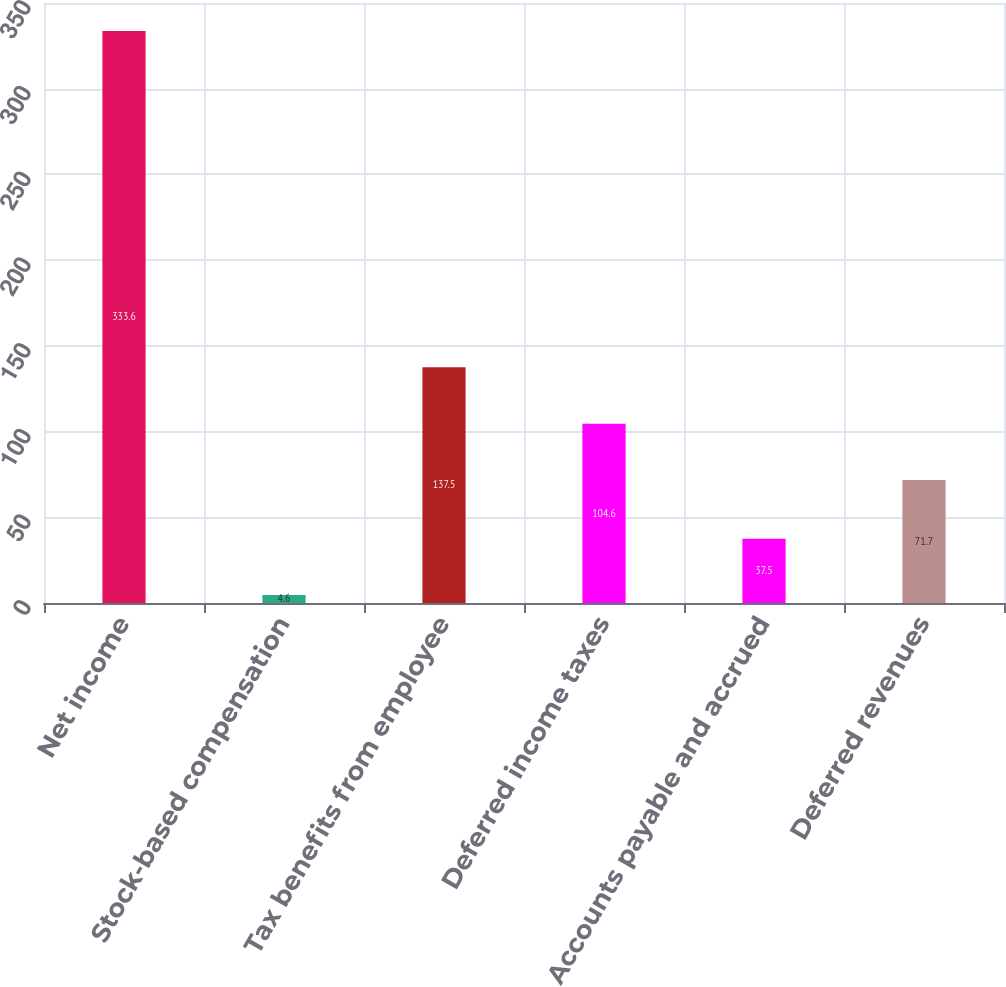Convert chart. <chart><loc_0><loc_0><loc_500><loc_500><bar_chart><fcel>Net income<fcel>Stock-based compensation<fcel>Tax benefits from employee<fcel>Deferred income taxes<fcel>Accounts payable and accrued<fcel>Deferred revenues<nl><fcel>333.6<fcel>4.6<fcel>137.5<fcel>104.6<fcel>37.5<fcel>71.7<nl></chart> 